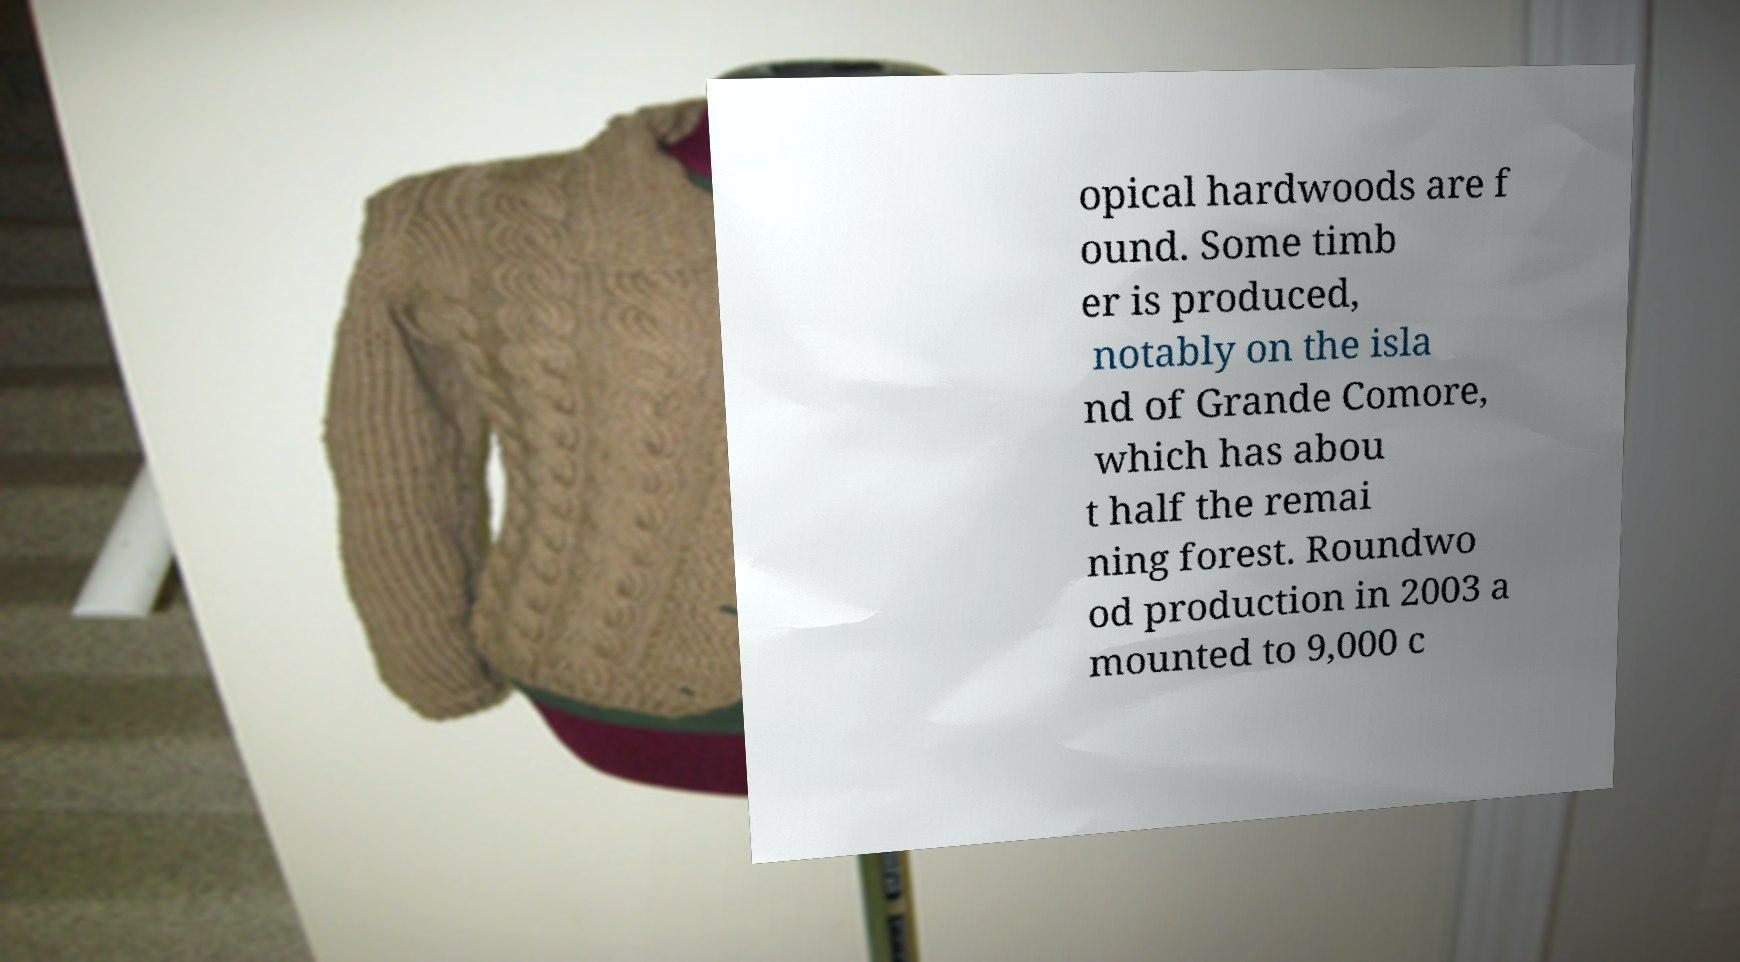Could you extract and type out the text from this image? opical hardwoods are f ound. Some timb er is produced, notably on the isla nd of Grande Comore, which has abou t half the remai ning forest. Roundwo od production in 2003 a mounted to 9,000 c 